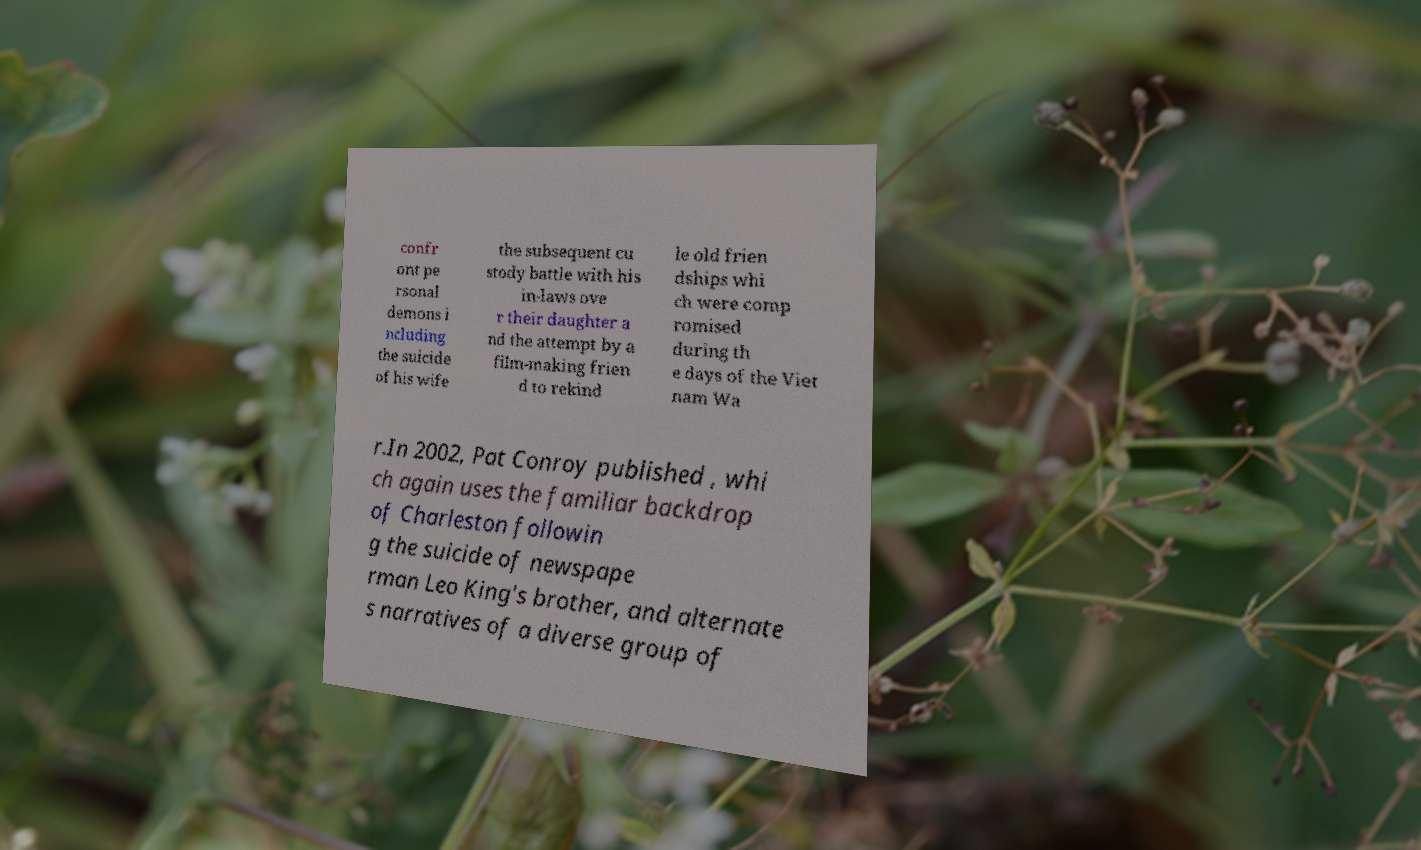Can you accurately transcribe the text from the provided image for me? confr ont pe rsonal demons i ncluding the suicide of his wife the subsequent cu stody battle with his in-laws ove r their daughter a nd the attempt by a film-making frien d to rekind le old frien dships whi ch were comp romised during th e days of the Viet nam Wa r.In 2002, Pat Conroy published , whi ch again uses the familiar backdrop of Charleston followin g the suicide of newspape rman Leo King's brother, and alternate s narratives of a diverse group of 